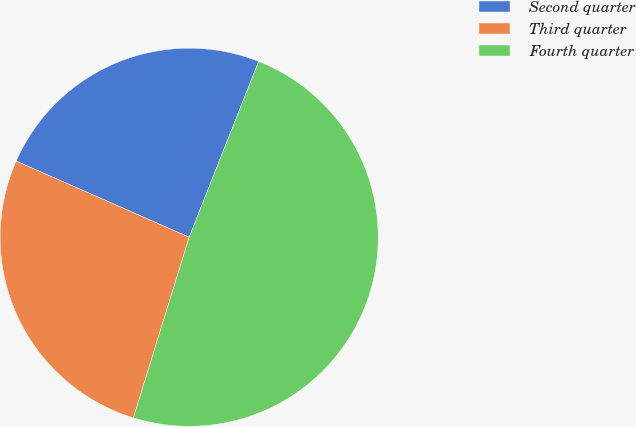<chart> <loc_0><loc_0><loc_500><loc_500><pie_chart><fcel>Second quarter<fcel>Third quarter<fcel>Fourth quarter<nl><fcel>24.39%<fcel>26.83%<fcel>48.78%<nl></chart> 